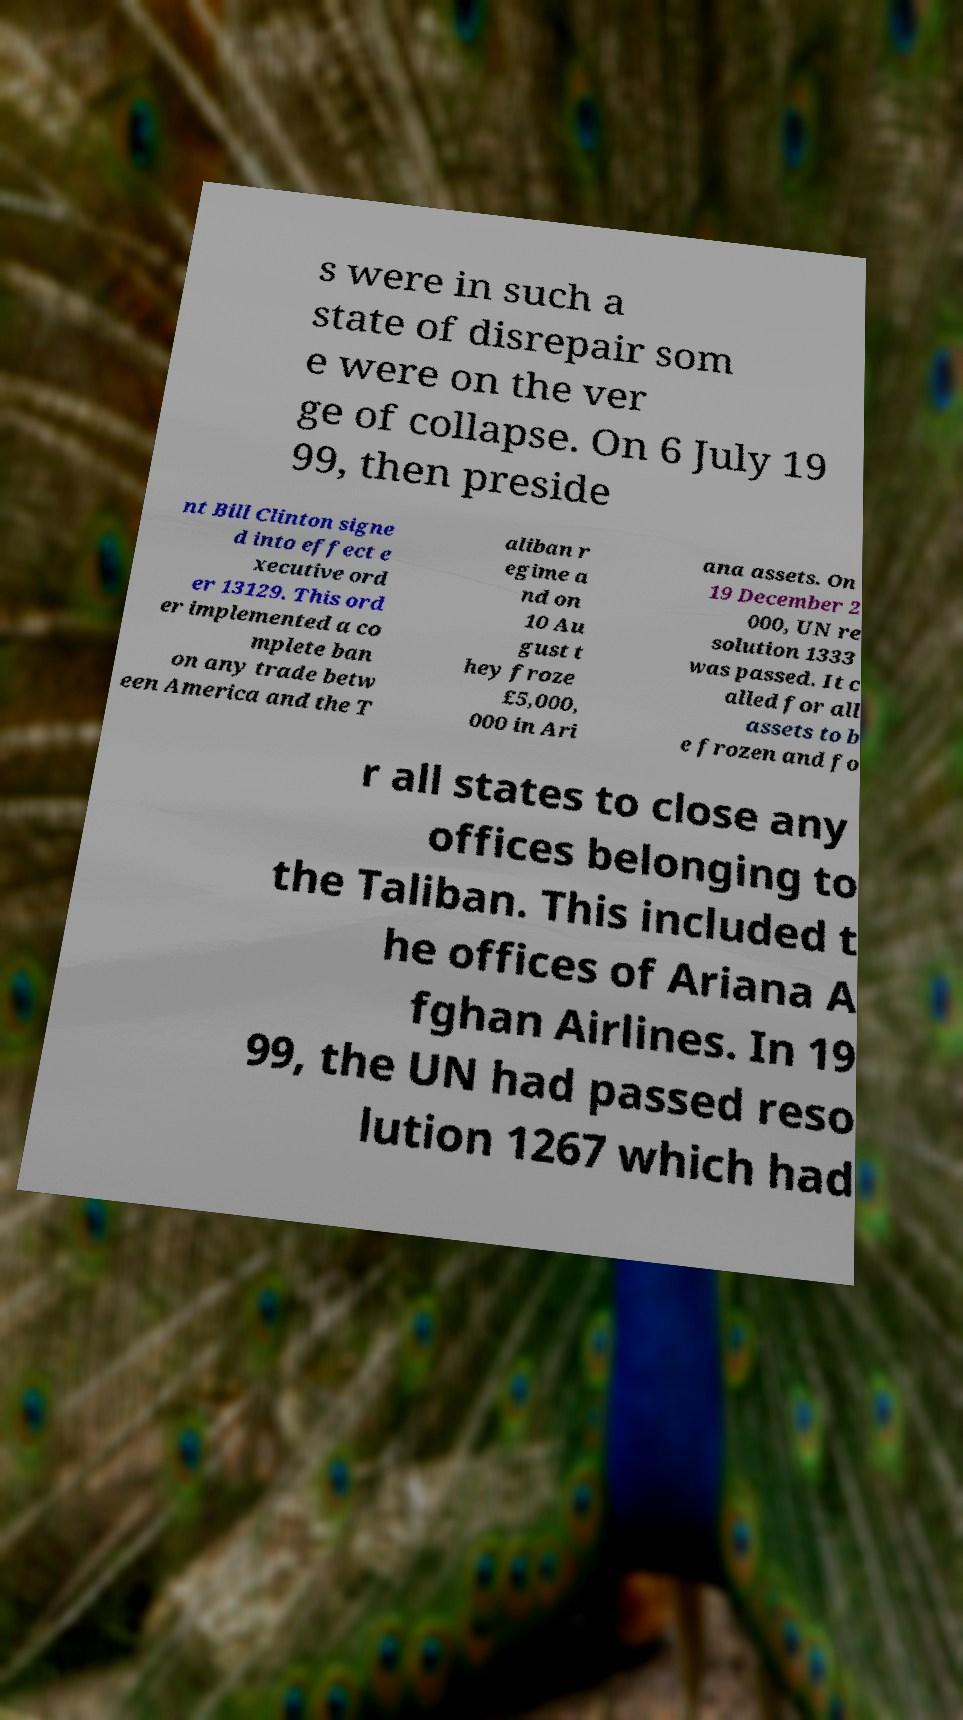Could you assist in decoding the text presented in this image and type it out clearly? s were in such a state of disrepair som e were on the ver ge of collapse. On 6 July 19 99, then preside nt Bill Clinton signe d into effect e xecutive ord er 13129. This ord er implemented a co mplete ban on any trade betw een America and the T aliban r egime a nd on 10 Au gust t hey froze £5,000, 000 in Ari ana assets. On 19 December 2 000, UN re solution 1333 was passed. It c alled for all assets to b e frozen and fo r all states to close any offices belonging to the Taliban. This included t he offices of Ariana A fghan Airlines. In 19 99, the UN had passed reso lution 1267 which had 